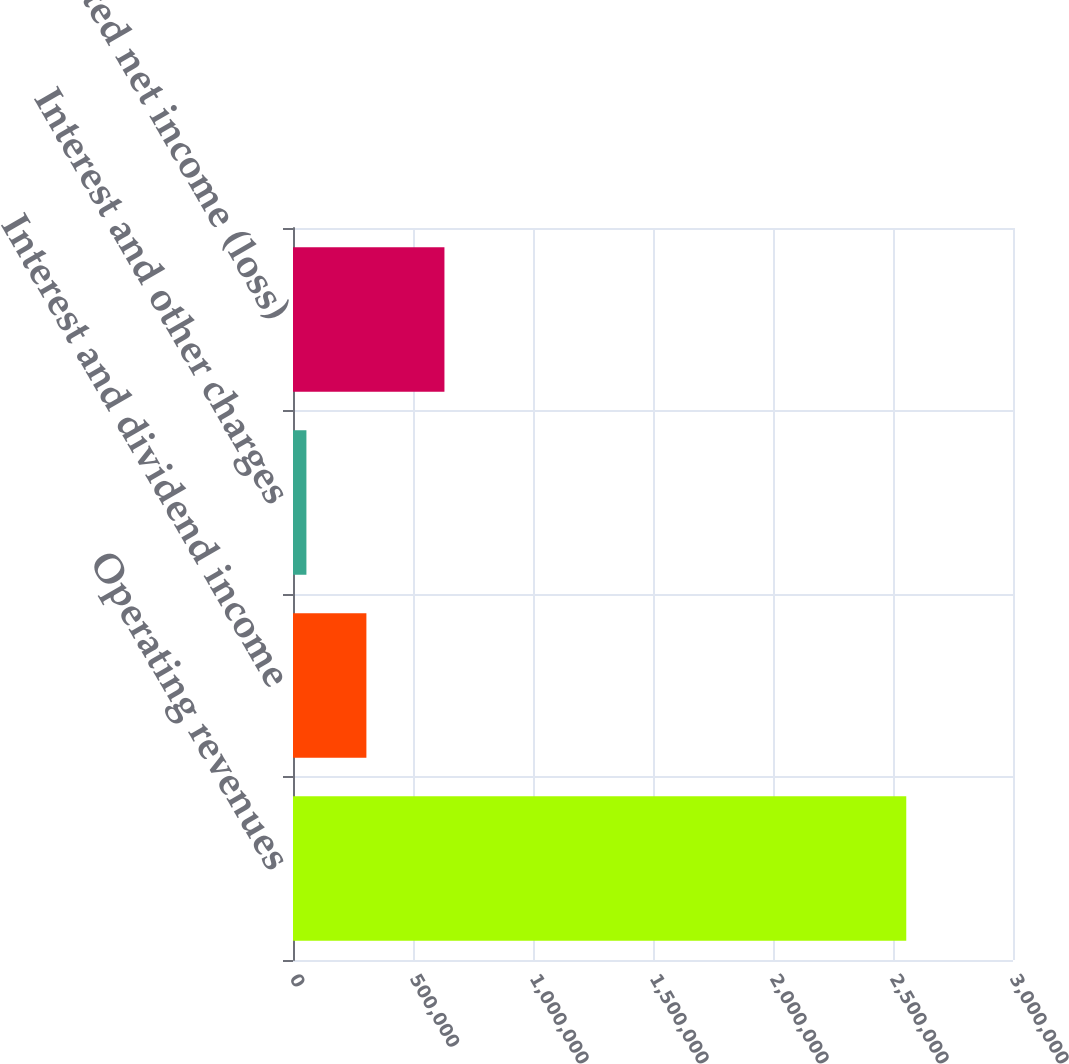<chart> <loc_0><loc_0><loc_500><loc_500><bar_chart><fcel>Operating revenues<fcel>Interest and dividend income<fcel>Interest and other charges<fcel>Consolidated net income (loss)<nl><fcel>2.55525e+06<fcel>305821<fcel>55884<fcel>631020<nl></chart> 